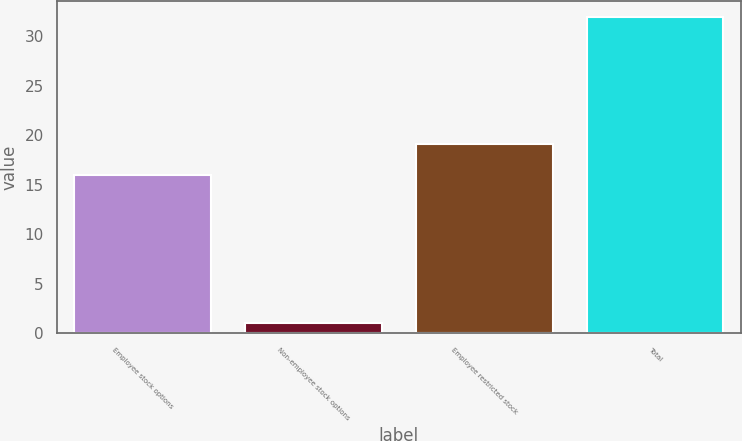<chart> <loc_0><loc_0><loc_500><loc_500><bar_chart><fcel>Employee stock options<fcel>Non-employee stock options<fcel>Employee restricted stock<fcel>Total<nl><fcel>16<fcel>1<fcel>19.1<fcel>32<nl></chart> 